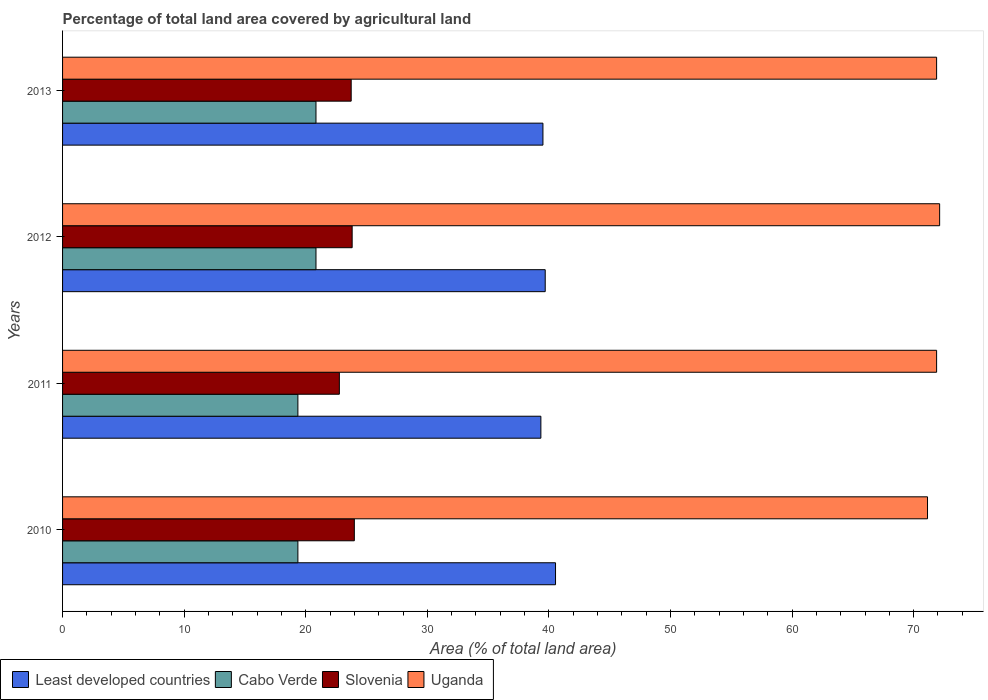How many different coloured bars are there?
Offer a terse response. 4. How many groups of bars are there?
Provide a short and direct response. 4. Are the number of bars on each tick of the Y-axis equal?
Offer a terse response. Yes. How many bars are there on the 2nd tick from the top?
Offer a terse response. 4. How many bars are there on the 4th tick from the bottom?
Provide a short and direct response. 4. What is the label of the 1st group of bars from the top?
Make the answer very short. 2013. In how many cases, is the number of bars for a given year not equal to the number of legend labels?
Give a very brief answer. 0. What is the percentage of agricultural land in Uganda in 2010?
Keep it short and to the point. 71.14. Across all years, what is the maximum percentage of agricultural land in Least developed countries?
Offer a terse response. 40.54. Across all years, what is the minimum percentage of agricultural land in Least developed countries?
Give a very brief answer. 39.34. In which year was the percentage of agricultural land in Least developed countries maximum?
Give a very brief answer. 2010. What is the total percentage of agricultural land in Slovenia in the graph?
Your response must be concise. 94.32. What is the difference between the percentage of agricultural land in Uganda in 2010 and the percentage of agricultural land in Least developed countries in 2011?
Make the answer very short. 31.8. What is the average percentage of agricultural land in Cabo Verde per year?
Give a very brief answer. 20.1. In the year 2010, what is the difference between the percentage of agricultural land in Least developed countries and percentage of agricultural land in Uganda?
Provide a succinct answer. -30.6. In how many years, is the percentage of agricultural land in Slovenia greater than 22 %?
Make the answer very short. 4. What is the ratio of the percentage of agricultural land in Uganda in 2010 to that in 2011?
Give a very brief answer. 0.99. Is the percentage of agricultural land in Slovenia in 2010 less than that in 2011?
Your answer should be very brief. No. Is the difference between the percentage of agricultural land in Least developed countries in 2012 and 2013 greater than the difference between the percentage of agricultural land in Uganda in 2012 and 2013?
Your answer should be very brief. No. What is the difference between the highest and the second highest percentage of agricultural land in Uganda?
Offer a very short reply. 0.25. What is the difference between the highest and the lowest percentage of agricultural land in Cabo Verde?
Provide a short and direct response. 1.49. In how many years, is the percentage of agricultural land in Least developed countries greater than the average percentage of agricultural land in Least developed countries taken over all years?
Your answer should be compact. 1. What does the 4th bar from the top in 2013 represents?
Your answer should be very brief. Least developed countries. What does the 4th bar from the bottom in 2013 represents?
Your response must be concise. Uganda. Is it the case that in every year, the sum of the percentage of agricultural land in Least developed countries and percentage of agricultural land in Slovenia is greater than the percentage of agricultural land in Cabo Verde?
Provide a succinct answer. Yes. How many bars are there?
Offer a very short reply. 16. Are all the bars in the graph horizontal?
Your answer should be very brief. Yes. How many years are there in the graph?
Make the answer very short. 4. What is the difference between two consecutive major ticks on the X-axis?
Provide a succinct answer. 10. Are the values on the major ticks of X-axis written in scientific E-notation?
Ensure brevity in your answer.  No. How are the legend labels stacked?
Make the answer very short. Horizontal. What is the title of the graph?
Provide a short and direct response. Percentage of total land area covered by agricultural land. Does "Middle income" appear as one of the legend labels in the graph?
Keep it short and to the point. No. What is the label or title of the X-axis?
Provide a short and direct response. Area (% of total land area). What is the label or title of the Y-axis?
Offer a terse response. Years. What is the Area (% of total land area) of Least developed countries in 2010?
Your answer should be compact. 40.54. What is the Area (% of total land area) in Cabo Verde in 2010?
Offer a terse response. 19.35. What is the Area (% of total land area) of Slovenia in 2010?
Keep it short and to the point. 24. What is the Area (% of total land area) in Uganda in 2010?
Keep it short and to the point. 71.14. What is the Area (% of total land area) of Least developed countries in 2011?
Your response must be concise. 39.34. What is the Area (% of total land area) of Cabo Verde in 2011?
Your answer should be compact. 19.35. What is the Area (% of total land area) of Slovenia in 2011?
Give a very brief answer. 22.77. What is the Area (% of total land area) in Uganda in 2011?
Make the answer very short. 71.89. What is the Area (% of total land area) of Least developed countries in 2012?
Your answer should be very brief. 39.7. What is the Area (% of total land area) in Cabo Verde in 2012?
Your answer should be compact. 20.84. What is the Area (% of total land area) in Slovenia in 2012?
Your answer should be very brief. 23.82. What is the Area (% of total land area) in Uganda in 2012?
Provide a short and direct response. 72.14. What is the Area (% of total land area) in Least developed countries in 2013?
Keep it short and to the point. 39.51. What is the Area (% of total land area) of Cabo Verde in 2013?
Provide a succinct answer. 20.84. What is the Area (% of total land area) in Slovenia in 2013?
Your response must be concise. 23.74. What is the Area (% of total land area) in Uganda in 2013?
Your answer should be very brief. 71.89. Across all years, what is the maximum Area (% of total land area) of Least developed countries?
Give a very brief answer. 40.54. Across all years, what is the maximum Area (% of total land area) in Cabo Verde?
Your response must be concise. 20.84. Across all years, what is the maximum Area (% of total land area) in Slovenia?
Offer a terse response. 24. Across all years, what is the maximum Area (% of total land area) in Uganda?
Provide a succinct answer. 72.14. Across all years, what is the minimum Area (% of total land area) of Least developed countries?
Ensure brevity in your answer.  39.34. Across all years, what is the minimum Area (% of total land area) in Cabo Verde?
Offer a terse response. 19.35. Across all years, what is the minimum Area (% of total land area) of Slovenia?
Your answer should be very brief. 22.77. Across all years, what is the minimum Area (% of total land area) of Uganda?
Provide a short and direct response. 71.14. What is the total Area (% of total land area) in Least developed countries in the graph?
Keep it short and to the point. 159.09. What is the total Area (% of total land area) of Cabo Verde in the graph?
Give a very brief answer. 80.4. What is the total Area (% of total land area) in Slovenia in the graph?
Keep it short and to the point. 94.32. What is the total Area (% of total land area) in Uganda in the graph?
Offer a very short reply. 287.05. What is the difference between the Area (% of total land area) in Least developed countries in 2010 and that in 2011?
Your answer should be compact. 1.21. What is the difference between the Area (% of total land area) of Cabo Verde in 2010 and that in 2011?
Your answer should be compact. 0. What is the difference between the Area (% of total land area) of Slovenia in 2010 and that in 2011?
Make the answer very short. 1.23. What is the difference between the Area (% of total land area) of Uganda in 2010 and that in 2011?
Offer a very short reply. -0.75. What is the difference between the Area (% of total land area) of Least developed countries in 2010 and that in 2012?
Ensure brevity in your answer.  0.85. What is the difference between the Area (% of total land area) in Cabo Verde in 2010 and that in 2012?
Give a very brief answer. -1.49. What is the difference between the Area (% of total land area) in Slovenia in 2010 and that in 2012?
Ensure brevity in your answer.  0.18. What is the difference between the Area (% of total land area) of Uganda in 2010 and that in 2012?
Keep it short and to the point. -1. What is the difference between the Area (% of total land area) in Least developed countries in 2010 and that in 2013?
Your answer should be compact. 1.03. What is the difference between the Area (% of total land area) of Cabo Verde in 2010 and that in 2013?
Ensure brevity in your answer.  -1.49. What is the difference between the Area (% of total land area) in Slovenia in 2010 and that in 2013?
Your response must be concise. 0.26. What is the difference between the Area (% of total land area) of Uganda in 2010 and that in 2013?
Provide a succinct answer. -0.75. What is the difference between the Area (% of total land area) of Least developed countries in 2011 and that in 2012?
Ensure brevity in your answer.  -0.36. What is the difference between the Area (% of total land area) of Cabo Verde in 2011 and that in 2012?
Offer a very short reply. -1.49. What is the difference between the Area (% of total land area) in Slovenia in 2011 and that in 2012?
Ensure brevity in your answer.  -1.05. What is the difference between the Area (% of total land area) of Uganda in 2011 and that in 2012?
Provide a succinct answer. -0.25. What is the difference between the Area (% of total land area) in Least developed countries in 2011 and that in 2013?
Provide a short and direct response. -0.17. What is the difference between the Area (% of total land area) of Cabo Verde in 2011 and that in 2013?
Your answer should be very brief. -1.49. What is the difference between the Area (% of total land area) of Slovenia in 2011 and that in 2013?
Provide a succinct answer. -0.97. What is the difference between the Area (% of total land area) of Least developed countries in 2012 and that in 2013?
Your response must be concise. 0.19. What is the difference between the Area (% of total land area) of Slovenia in 2012 and that in 2013?
Keep it short and to the point. 0.08. What is the difference between the Area (% of total land area) in Uganda in 2012 and that in 2013?
Offer a terse response. 0.25. What is the difference between the Area (% of total land area) in Least developed countries in 2010 and the Area (% of total land area) in Cabo Verde in 2011?
Offer a terse response. 21.19. What is the difference between the Area (% of total land area) of Least developed countries in 2010 and the Area (% of total land area) of Slovenia in 2011?
Provide a succinct answer. 17.78. What is the difference between the Area (% of total land area) of Least developed countries in 2010 and the Area (% of total land area) of Uganda in 2011?
Your answer should be compact. -31.34. What is the difference between the Area (% of total land area) in Cabo Verde in 2010 and the Area (% of total land area) in Slovenia in 2011?
Provide a short and direct response. -3.41. What is the difference between the Area (% of total land area) in Cabo Verde in 2010 and the Area (% of total land area) in Uganda in 2011?
Your answer should be very brief. -52.53. What is the difference between the Area (% of total land area) of Slovenia in 2010 and the Area (% of total land area) of Uganda in 2011?
Provide a short and direct response. -47.89. What is the difference between the Area (% of total land area) in Least developed countries in 2010 and the Area (% of total land area) in Cabo Verde in 2012?
Provide a short and direct response. 19.7. What is the difference between the Area (% of total land area) in Least developed countries in 2010 and the Area (% of total land area) in Slovenia in 2012?
Make the answer very short. 16.73. What is the difference between the Area (% of total land area) in Least developed countries in 2010 and the Area (% of total land area) in Uganda in 2012?
Your answer should be compact. -31.59. What is the difference between the Area (% of total land area) of Cabo Verde in 2010 and the Area (% of total land area) of Slovenia in 2012?
Offer a very short reply. -4.46. What is the difference between the Area (% of total land area) of Cabo Verde in 2010 and the Area (% of total land area) of Uganda in 2012?
Keep it short and to the point. -52.78. What is the difference between the Area (% of total land area) of Slovenia in 2010 and the Area (% of total land area) of Uganda in 2012?
Ensure brevity in your answer.  -48.14. What is the difference between the Area (% of total land area) in Least developed countries in 2010 and the Area (% of total land area) in Cabo Verde in 2013?
Keep it short and to the point. 19.7. What is the difference between the Area (% of total land area) of Least developed countries in 2010 and the Area (% of total land area) of Slovenia in 2013?
Provide a short and direct response. 16.81. What is the difference between the Area (% of total land area) of Least developed countries in 2010 and the Area (% of total land area) of Uganda in 2013?
Provide a short and direct response. -31.34. What is the difference between the Area (% of total land area) of Cabo Verde in 2010 and the Area (% of total land area) of Slovenia in 2013?
Your answer should be very brief. -4.38. What is the difference between the Area (% of total land area) of Cabo Verde in 2010 and the Area (% of total land area) of Uganda in 2013?
Your response must be concise. -52.53. What is the difference between the Area (% of total land area) of Slovenia in 2010 and the Area (% of total land area) of Uganda in 2013?
Your response must be concise. -47.89. What is the difference between the Area (% of total land area) in Least developed countries in 2011 and the Area (% of total land area) in Cabo Verde in 2012?
Your answer should be compact. 18.5. What is the difference between the Area (% of total land area) in Least developed countries in 2011 and the Area (% of total land area) in Slovenia in 2012?
Provide a succinct answer. 15.52. What is the difference between the Area (% of total land area) of Least developed countries in 2011 and the Area (% of total land area) of Uganda in 2012?
Offer a terse response. -32.8. What is the difference between the Area (% of total land area) of Cabo Verde in 2011 and the Area (% of total land area) of Slovenia in 2012?
Keep it short and to the point. -4.46. What is the difference between the Area (% of total land area) of Cabo Verde in 2011 and the Area (% of total land area) of Uganda in 2012?
Offer a terse response. -52.78. What is the difference between the Area (% of total land area) in Slovenia in 2011 and the Area (% of total land area) in Uganda in 2012?
Offer a terse response. -49.37. What is the difference between the Area (% of total land area) in Least developed countries in 2011 and the Area (% of total land area) in Cabo Verde in 2013?
Ensure brevity in your answer.  18.5. What is the difference between the Area (% of total land area) of Least developed countries in 2011 and the Area (% of total land area) of Slovenia in 2013?
Keep it short and to the point. 15.6. What is the difference between the Area (% of total land area) in Least developed countries in 2011 and the Area (% of total land area) in Uganda in 2013?
Keep it short and to the point. -32.55. What is the difference between the Area (% of total land area) in Cabo Verde in 2011 and the Area (% of total land area) in Slovenia in 2013?
Make the answer very short. -4.38. What is the difference between the Area (% of total land area) of Cabo Verde in 2011 and the Area (% of total land area) of Uganda in 2013?
Ensure brevity in your answer.  -52.53. What is the difference between the Area (% of total land area) of Slovenia in 2011 and the Area (% of total land area) of Uganda in 2013?
Make the answer very short. -49.12. What is the difference between the Area (% of total land area) in Least developed countries in 2012 and the Area (% of total land area) in Cabo Verde in 2013?
Give a very brief answer. 18.85. What is the difference between the Area (% of total land area) in Least developed countries in 2012 and the Area (% of total land area) in Slovenia in 2013?
Offer a terse response. 15.96. What is the difference between the Area (% of total land area) in Least developed countries in 2012 and the Area (% of total land area) in Uganda in 2013?
Ensure brevity in your answer.  -32.19. What is the difference between the Area (% of total land area) in Cabo Verde in 2012 and the Area (% of total land area) in Slovenia in 2013?
Provide a short and direct response. -2.9. What is the difference between the Area (% of total land area) in Cabo Verde in 2012 and the Area (% of total land area) in Uganda in 2013?
Provide a short and direct response. -51.04. What is the difference between the Area (% of total land area) in Slovenia in 2012 and the Area (% of total land area) in Uganda in 2013?
Give a very brief answer. -48.07. What is the average Area (% of total land area) in Least developed countries per year?
Ensure brevity in your answer.  39.77. What is the average Area (% of total land area) of Cabo Verde per year?
Provide a succinct answer. 20.1. What is the average Area (% of total land area) in Slovenia per year?
Your answer should be compact. 23.58. What is the average Area (% of total land area) in Uganda per year?
Provide a short and direct response. 71.76. In the year 2010, what is the difference between the Area (% of total land area) in Least developed countries and Area (% of total land area) in Cabo Verde?
Your answer should be compact. 21.19. In the year 2010, what is the difference between the Area (% of total land area) in Least developed countries and Area (% of total land area) in Slovenia?
Offer a terse response. 16.55. In the year 2010, what is the difference between the Area (% of total land area) of Least developed countries and Area (% of total land area) of Uganda?
Make the answer very short. -30.6. In the year 2010, what is the difference between the Area (% of total land area) of Cabo Verde and Area (% of total land area) of Slovenia?
Provide a succinct answer. -4.64. In the year 2010, what is the difference between the Area (% of total land area) in Cabo Verde and Area (% of total land area) in Uganda?
Offer a terse response. -51.79. In the year 2010, what is the difference between the Area (% of total land area) of Slovenia and Area (% of total land area) of Uganda?
Give a very brief answer. -47.14. In the year 2011, what is the difference between the Area (% of total land area) of Least developed countries and Area (% of total land area) of Cabo Verde?
Offer a very short reply. 19.98. In the year 2011, what is the difference between the Area (% of total land area) in Least developed countries and Area (% of total land area) in Slovenia?
Ensure brevity in your answer.  16.57. In the year 2011, what is the difference between the Area (% of total land area) of Least developed countries and Area (% of total land area) of Uganda?
Provide a succinct answer. -32.55. In the year 2011, what is the difference between the Area (% of total land area) of Cabo Verde and Area (% of total land area) of Slovenia?
Your response must be concise. -3.41. In the year 2011, what is the difference between the Area (% of total land area) in Cabo Verde and Area (% of total land area) in Uganda?
Your answer should be compact. -52.53. In the year 2011, what is the difference between the Area (% of total land area) in Slovenia and Area (% of total land area) in Uganda?
Offer a very short reply. -49.12. In the year 2012, what is the difference between the Area (% of total land area) of Least developed countries and Area (% of total land area) of Cabo Verde?
Your response must be concise. 18.85. In the year 2012, what is the difference between the Area (% of total land area) of Least developed countries and Area (% of total land area) of Slovenia?
Ensure brevity in your answer.  15.88. In the year 2012, what is the difference between the Area (% of total land area) in Least developed countries and Area (% of total land area) in Uganda?
Give a very brief answer. -32.44. In the year 2012, what is the difference between the Area (% of total land area) in Cabo Verde and Area (% of total land area) in Slovenia?
Provide a short and direct response. -2.97. In the year 2012, what is the difference between the Area (% of total land area) in Cabo Verde and Area (% of total land area) in Uganda?
Your answer should be very brief. -51.29. In the year 2012, what is the difference between the Area (% of total land area) in Slovenia and Area (% of total land area) in Uganda?
Your answer should be compact. -48.32. In the year 2013, what is the difference between the Area (% of total land area) of Least developed countries and Area (% of total land area) of Cabo Verde?
Ensure brevity in your answer.  18.67. In the year 2013, what is the difference between the Area (% of total land area) in Least developed countries and Area (% of total land area) in Slovenia?
Offer a terse response. 15.77. In the year 2013, what is the difference between the Area (% of total land area) in Least developed countries and Area (% of total land area) in Uganda?
Give a very brief answer. -32.38. In the year 2013, what is the difference between the Area (% of total land area) in Cabo Verde and Area (% of total land area) in Slovenia?
Keep it short and to the point. -2.9. In the year 2013, what is the difference between the Area (% of total land area) in Cabo Verde and Area (% of total land area) in Uganda?
Offer a very short reply. -51.04. In the year 2013, what is the difference between the Area (% of total land area) in Slovenia and Area (% of total land area) in Uganda?
Offer a terse response. -48.15. What is the ratio of the Area (% of total land area) in Least developed countries in 2010 to that in 2011?
Offer a very short reply. 1.03. What is the ratio of the Area (% of total land area) of Cabo Verde in 2010 to that in 2011?
Provide a succinct answer. 1. What is the ratio of the Area (% of total land area) in Slovenia in 2010 to that in 2011?
Provide a succinct answer. 1.05. What is the ratio of the Area (% of total land area) of Uganda in 2010 to that in 2011?
Your answer should be very brief. 0.99. What is the ratio of the Area (% of total land area) of Least developed countries in 2010 to that in 2012?
Ensure brevity in your answer.  1.02. What is the ratio of the Area (% of total land area) in Cabo Verde in 2010 to that in 2012?
Offer a terse response. 0.93. What is the ratio of the Area (% of total land area) of Slovenia in 2010 to that in 2012?
Your answer should be compact. 1.01. What is the ratio of the Area (% of total land area) in Uganda in 2010 to that in 2012?
Your answer should be compact. 0.99. What is the ratio of the Area (% of total land area) in Least developed countries in 2010 to that in 2013?
Provide a succinct answer. 1.03. What is the ratio of the Area (% of total land area) of Cabo Verde in 2010 to that in 2013?
Ensure brevity in your answer.  0.93. What is the ratio of the Area (% of total land area) of Slovenia in 2010 to that in 2013?
Keep it short and to the point. 1.01. What is the ratio of the Area (% of total land area) in Least developed countries in 2011 to that in 2012?
Your answer should be compact. 0.99. What is the ratio of the Area (% of total land area) in Slovenia in 2011 to that in 2012?
Ensure brevity in your answer.  0.96. What is the ratio of the Area (% of total land area) in Slovenia in 2011 to that in 2013?
Give a very brief answer. 0.96. What is the ratio of the Area (% of total land area) of Least developed countries in 2012 to that in 2013?
Ensure brevity in your answer.  1. What is the ratio of the Area (% of total land area) of Cabo Verde in 2012 to that in 2013?
Ensure brevity in your answer.  1. What is the ratio of the Area (% of total land area) of Slovenia in 2012 to that in 2013?
Offer a very short reply. 1. What is the ratio of the Area (% of total land area) of Uganda in 2012 to that in 2013?
Your answer should be compact. 1. What is the difference between the highest and the second highest Area (% of total land area) in Least developed countries?
Your answer should be compact. 0.85. What is the difference between the highest and the second highest Area (% of total land area) in Slovenia?
Offer a terse response. 0.18. What is the difference between the highest and the second highest Area (% of total land area) in Uganda?
Offer a terse response. 0.25. What is the difference between the highest and the lowest Area (% of total land area) of Least developed countries?
Your answer should be compact. 1.21. What is the difference between the highest and the lowest Area (% of total land area) in Cabo Verde?
Make the answer very short. 1.49. What is the difference between the highest and the lowest Area (% of total land area) in Slovenia?
Your answer should be compact. 1.23. What is the difference between the highest and the lowest Area (% of total land area) in Uganda?
Make the answer very short. 1. 